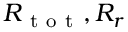Convert formula to latex. <formula><loc_0><loc_0><loc_500><loc_500>R _ { t o t } , R _ { r }</formula> 